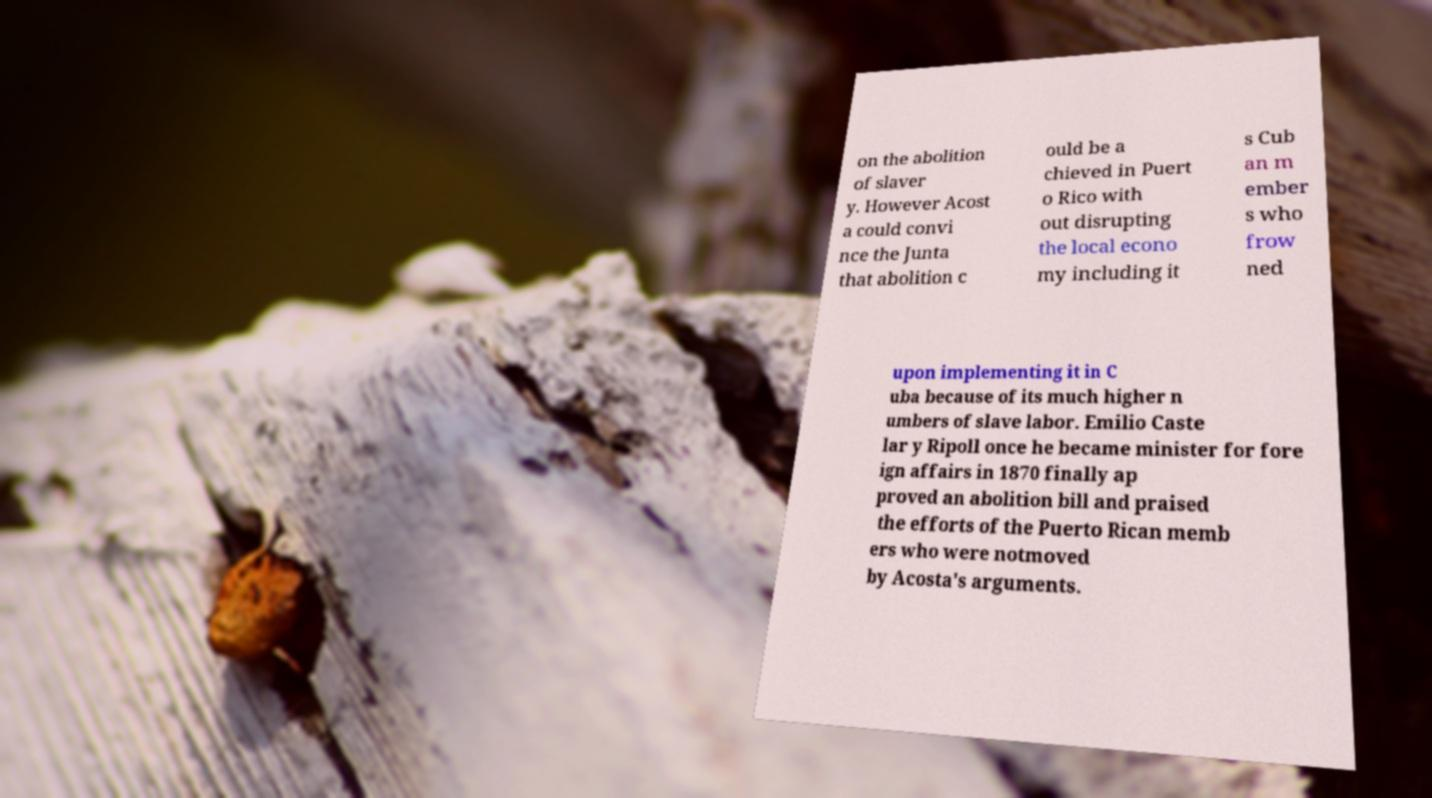Please identify and transcribe the text found in this image. on the abolition of slaver y. However Acost a could convi nce the Junta that abolition c ould be a chieved in Puert o Rico with out disrupting the local econo my including it s Cub an m ember s who frow ned upon implementing it in C uba because of its much higher n umbers of slave labor. Emilio Caste lar y Ripoll once he became minister for fore ign affairs in 1870 finally ap proved an abolition bill and praised the efforts of the Puerto Rican memb ers who were notmoved by Acosta's arguments. 